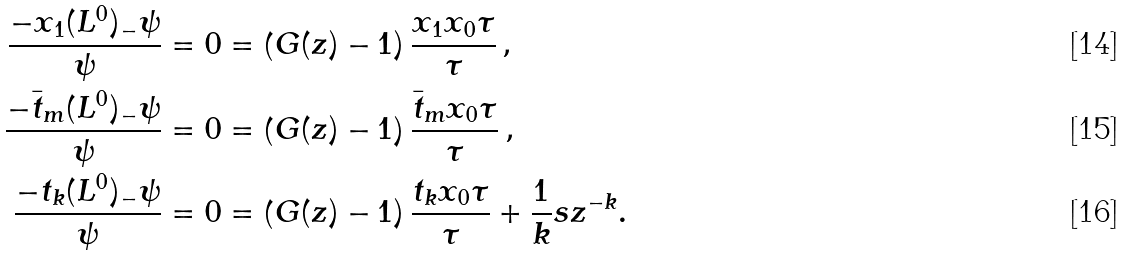<formula> <loc_0><loc_0><loc_500><loc_500>\frac { - x _ { 1 } ( L ^ { 0 } ) _ { - } \psi } { \psi } & = 0 = \left ( G ( z ) - 1 \right ) \frac { x _ { 1 } x _ { 0 } \tau } { \tau } \, , \\ \frac { - \bar { t } _ { m } ( L ^ { 0 } ) _ { - } \psi } { \psi } & = 0 = \left ( G ( z ) - 1 \right ) \frac { \bar { t } _ { m } x _ { 0 } \tau } { \tau } \, , \\ \frac { - t _ { k } ( L ^ { 0 } ) _ { - } \psi } { \psi } & = 0 = \left ( G ( z ) - 1 \right ) \frac { t _ { k } x _ { 0 } \tau } { \tau } + \frac { 1 } { k } s z ^ { - k } .</formula> 